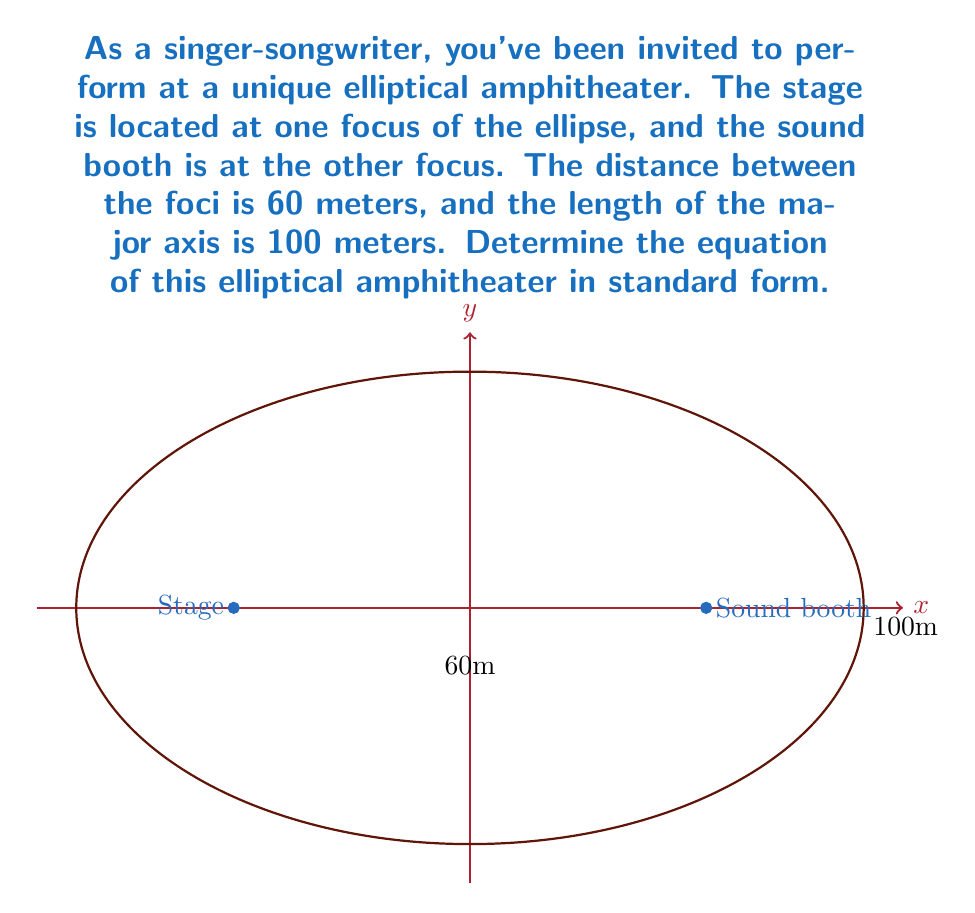Show me your answer to this math problem. Let's solve this step-by-step:

1) The standard form of an ellipse centered at the origin is:

   $$\frac{x^2}{a^2} + \frac{y^2}{b^2} = 1$$

   where $a$ is the length of the semi-major axis and $b$ is the length of the semi-minor axis.

2) We're given that the length of the major axis is 100 meters. So, $2a = 100$, or $a = 50$.

3) The distance between the foci is 60 meters. In an ellipse, this distance is $2c$, where $c^2 = a^2 - b^2$. So, $2c = 60$, or $c = 30$.

4) We can now find $b$ using the equation $c^2 = a^2 - b^2$:

   $30^2 = 50^2 - b^2$
   $900 = 2500 - b^2$
   $b^2 = 2500 - 900 = 1600$
   $b = 40$

5) Now we have $a = 50$ and $b = 40$. We can substitute these into the standard form equation:

   $$\frac{x^2}{50^2} + \frac{y^2}{40^2} = 1$$

6) Simplifying:

   $$\frac{x^2}{2500} + \frac{y^2}{1600} = 1$$

This is the equation of the elliptical amphitheater in standard form.
Answer: $$\frac{x^2}{2500} + \frac{y^2}{1600} = 1$$ 